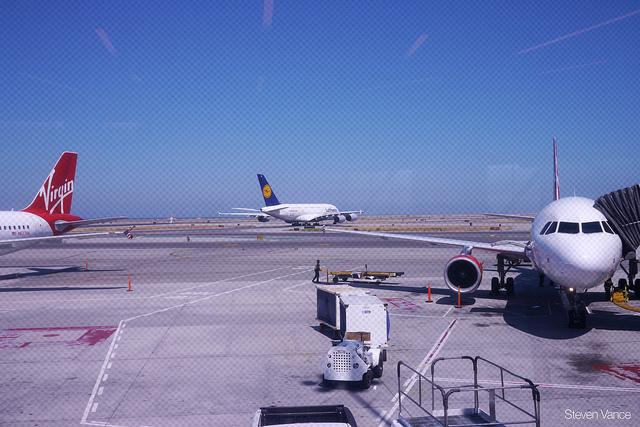What color is the tail fin on the furthest left side of the tarmac? Please explain your reasoning. red. The one furthest away is a blue color. 